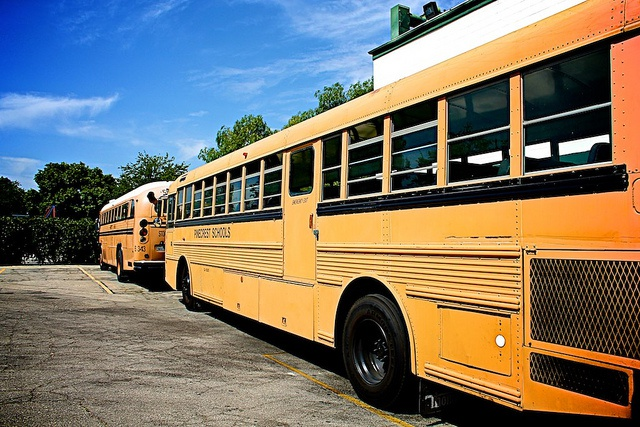Describe the objects in this image and their specific colors. I can see bus in darkblue, black, orange, and khaki tones and bus in darkblue, orange, black, white, and tan tones in this image. 